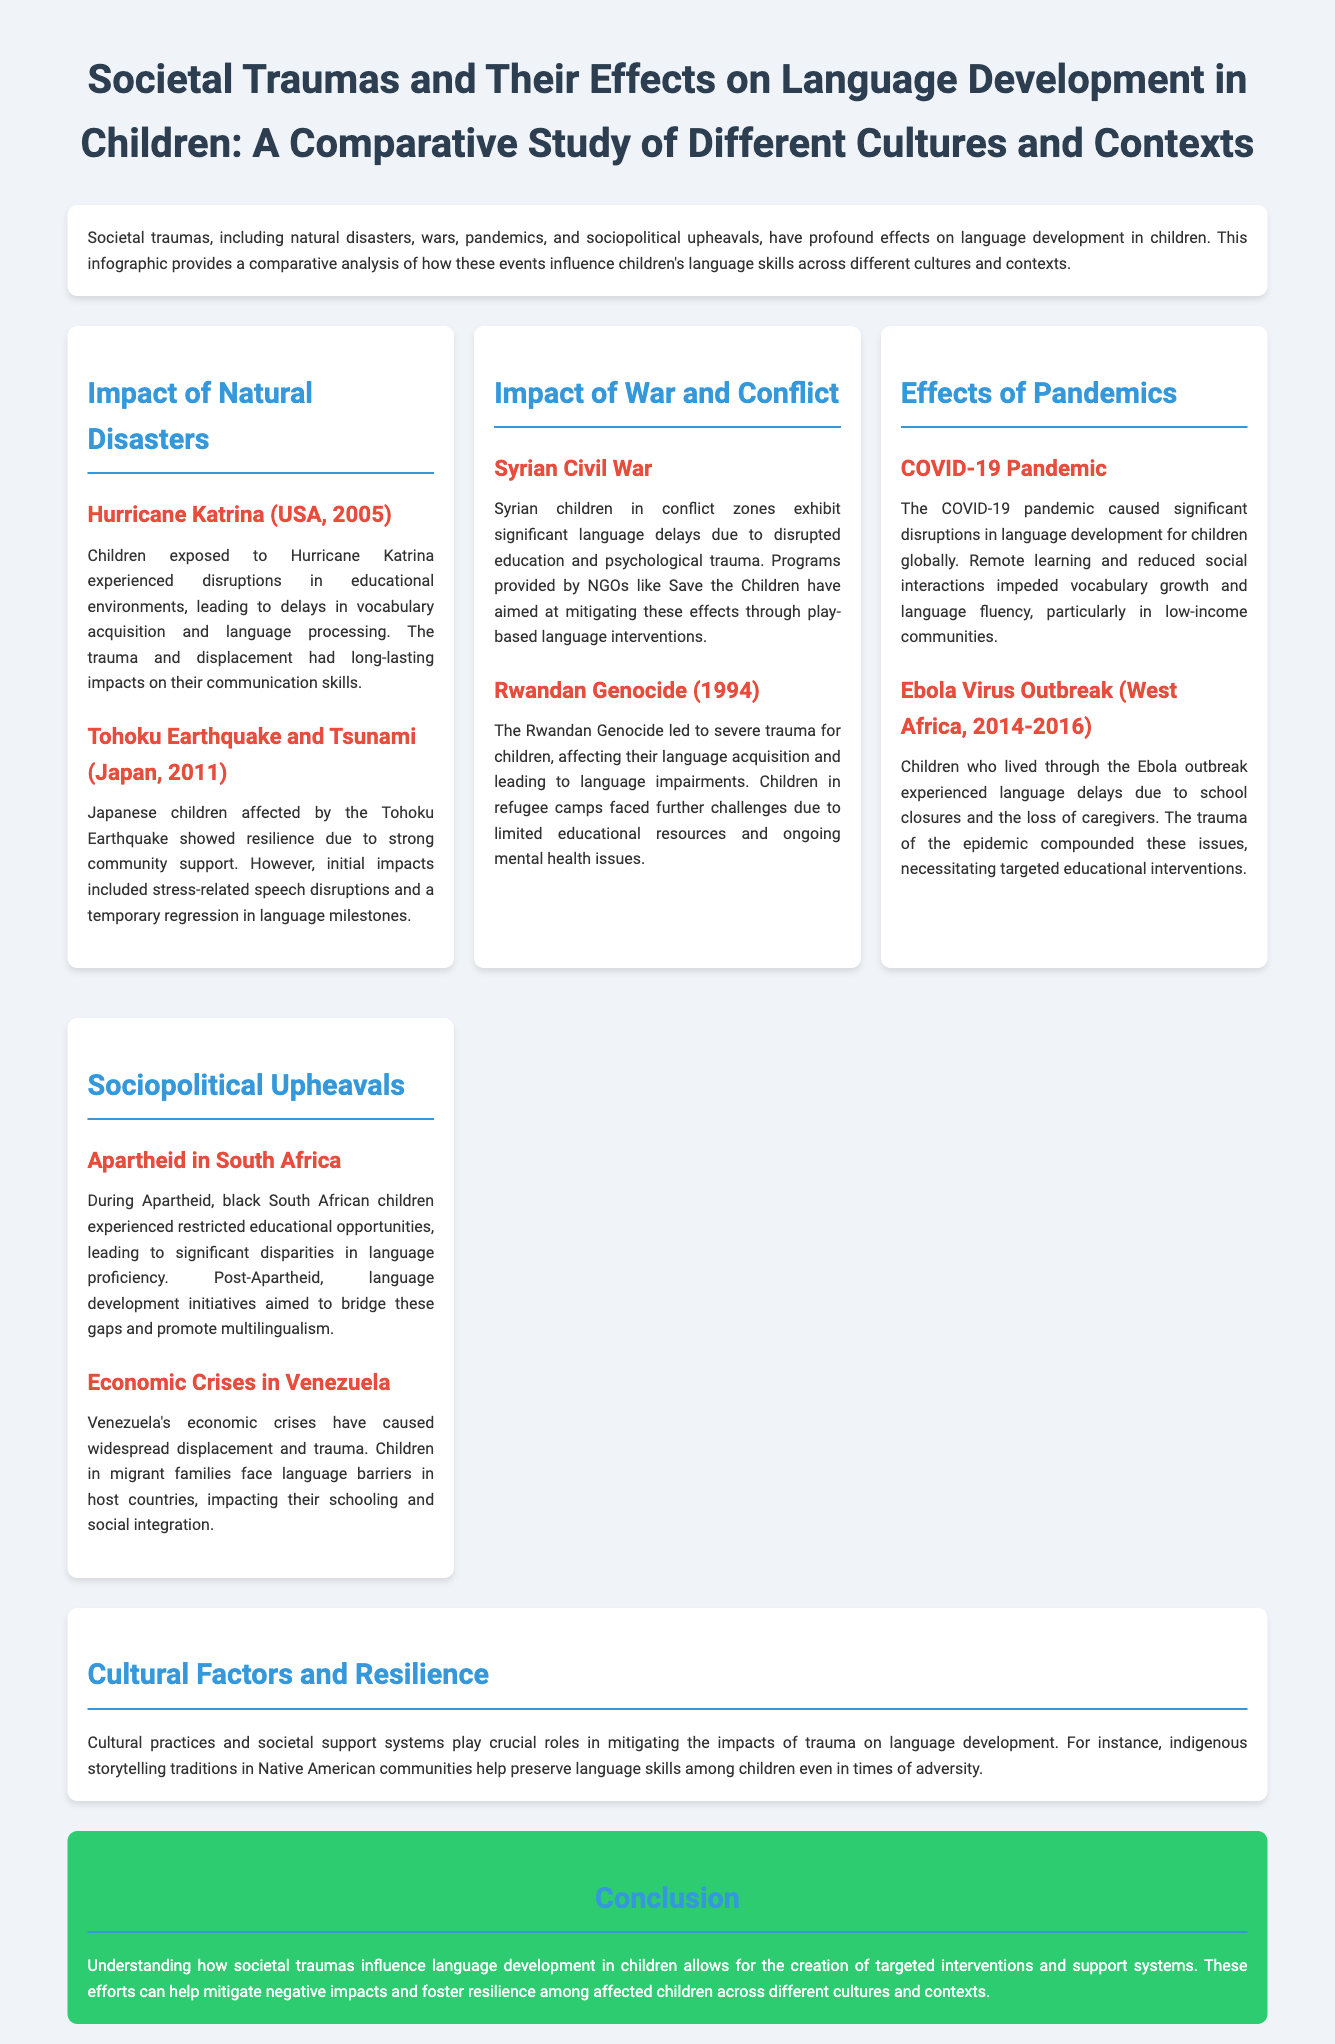What societal events are discussed in this infographic? The infographic discusses several societal events, including natural disasters, wars, pandemics, and sociopolitical upheavals.
Answer: natural disasters, wars, pandemics, sociopolitical upheavals What year did Hurricane Katrina occur? The document specifically states the year of Hurricane Katrina's occurrence.
Answer: 2005 Which organization provides programs to mitigate language delays in Syrian children? The document names an NGO involved in addressing the language delays caused by the Syrian Civil War.
Answer: Save the Children What cultural factor aids resilience in language development among children? The infographic discusses a specific cultural practice that helps preserve language skills during adversity.
Answer: indigenous storytelling traditions How did the COVID-19 pandemic affect children's language development? The document describes the impact of COVID-19 on children's language skills, particularly during a specific type of learning.
Answer: remote learning What was one outcome for children in Venezuela due to economic crises? The infographic provides information about the social challenges faced by children as a result of the crises in Venezuela.
Answer: language barriers What was the initial impact on Japanese children after the Tohoku earthquake? The document mentions a specific effect that occurred shortly after the Tohoku earthquake on language development.
Answer: stress-related speech disruptions What did the Rwandan Genocide result in regarding language acquisition? The document discusses a specific negative effect on language acquisition due to the genocide.
Answer: language impairments What role do cultural practices play in language development according to the document? The infographic indicates how cultural practices influence the effects of trauma on language development in children.
Answer: mitigating impacts of trauma 